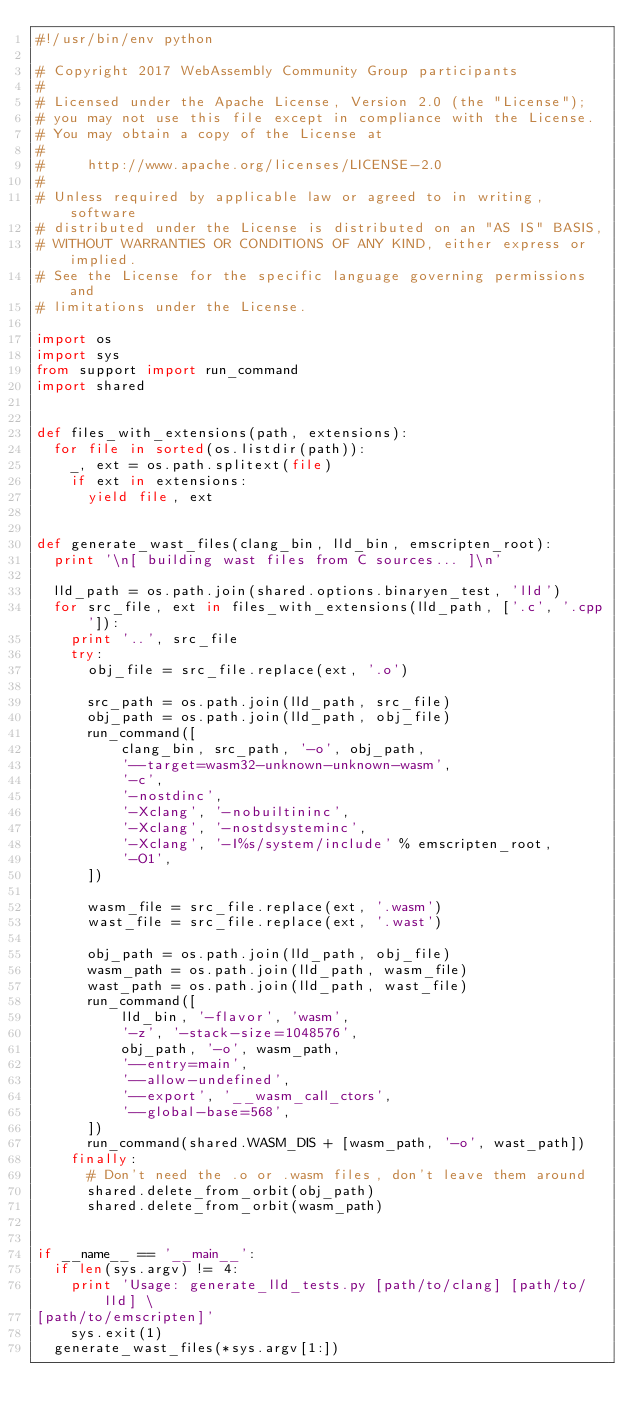<code> <loc_0><loc_0><loc_500><loc_500><_Python_>#!/usr/bin/env python

# Copyright 2017 WebAssembly Community Group participants
#
# Licensed under the Apache License, Version 2.0 (the "License");
# you may not use this file except in compliance with the License.
# You may obtain a copy of the License at
#
#     http://www.apache.org/licenses/LICENSE-2.0
#
# Unless required by applicable law or agreed to in writing, software
# distributed under the License is distributed on an "AS IS" BASIS,
# WITHOUT WARRANTIES OR CONDITIONS OF ANY KIND, either express or implied.
# See the License for the specific language governing permissions and
# limitations under the License.

import os
import sys
from support import run_command
import shared


def files_with_extensions(path, extensions):
  for file in sorted(os.listdir(path)):
    _, ext = os.path.splitext(file)
    if ext in extensions:
      yield file, ext


def generate_wast_files(clang_bin, lld_bin, emscripten_root):
  print '\n[ building wast files from C sources... ]\n'

  lld_path = os.path.join(shared.options.binaryen_test, 'lld')
  for src_file, ext in files_with_extensions(lld_path, ['.c', '.cpp']):
    print '..', src_file
    try:
      obj_file = src_file.replace(ext, '.o')

      src_path = os.path.join(lld_path, src_file)
      obj_path = os.path.join(lld_path, obj_file)
      run_command([
          clang_bin, src_path, '-o', obj_path,
          '--target=wasm32-unknown-unknown-wasm',
          '-c',
          '-nostdinc',
          '-Xclang', '-nobuiltininc',
          '-Xclang', '-nostdsysteminc',
          '-Xclang', '-I%s/system/include' % emscripten_root,
          '-O1',
      ])

      wasm_file = src_file.replace(ext, '.wasm')
      wast_file = src_file.replace(ext, '.wast')

      obj_path = os.path.join(lld_path, obj_file)
      wasm_path = os.path.join(lld_path, wasm_file)
      wast_path = os.path.join(lld_path, wast_file)
      run_command([
          lld_bin, '-flavor', 'wasm',
          '-z', '-stack-size=1048576',
          obj_path, '-o', wasm_path,
          '--entry=main',
          '--allow-undefined',
          '--export', '__wasm_call_ctors',
          '--global-base=568',
      ])
      run_command(shared.WASM_DIS + [wasm_path, '-o', wast_path])
    finally:
      # Don't need the .o or .wasm files, don't leave them around
      shared.delete_from_orbit(obj_path)
      shared.delete_from_orbit(wasm_path)


if __name__ == '__main__':
  if len(sys.argv) != 4:
    print 'Usage: generate_lld_tests.py [path/to/clang] [path/to/lld] \
[path/to/emscripten]'
    sys.exit(1)
  generate_wast_files(*sys.argv[1:])
</code> 